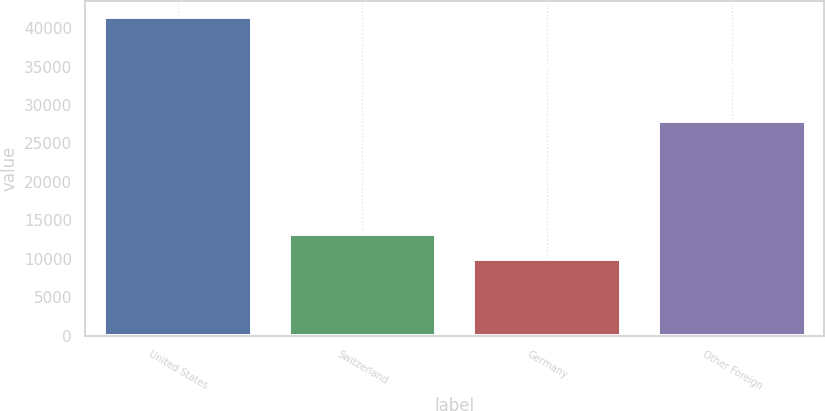Convert chart. <chart><loc_0><loc_0><loc_500><loc_500><bar_chart><fcel>United States<fcel>Switzerland<fcel>Germany<fcel>Other Foreign<nl><fcel>41427<fcel>13168.8<fcel>10029<fcel>27881<nl></chart> 